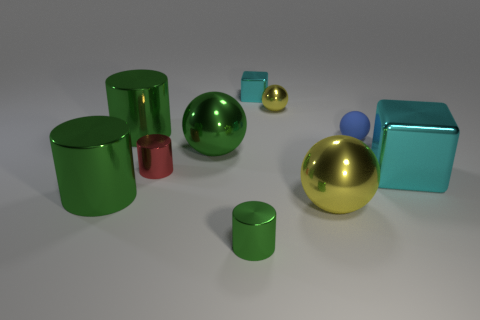Do the blue rubber thing and the green shiny sphere have the same size?
Ensure brevity in your answer.  No. Are the ball behind the tiny rubber sphere and the blue thing made of the same material?
Your answer should be very brief. No. Are there more large green objects left of the big cyan object than small cylinders that are in front of the small green object?
Keep it short and to the point. Yes. There is another sphere that is the same size as the blue sphere; what material is it?
Provide a short and direct response. Metal. What number of other objects are the same material as the tiny yellow sphere?
Your answer should be very brief. 8. There is a cyan shiny object in front of the tiny block; does it have the same shape as the thing behind the tiny yellow ball?
Your answer should be compact. Yes. How many other things are the same color as the rubber object?
Your answer should be very brief. 0. Do the cyan object that is on the left side of the blue matte thing and the tiny object right of the small yellow metal ball have the same material?
Your answer should be compact. No. Is the number of objects that are on the left side of the big cyan shiny cube the same as the number of big green spheres in front of the small red metal object?
Make the answer very short. No. There is a cyan thing that is in front of the small shiny block; what is it made of?
Your answer should be very brief. Metal. 